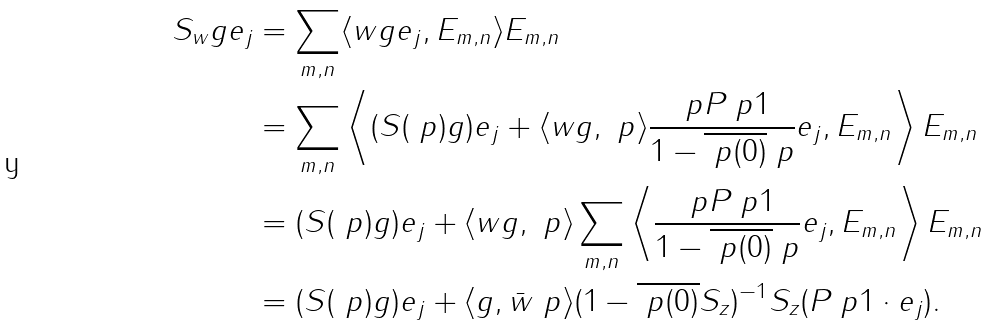Convert formula to latex. <formula><loc_0><loc_0><loc_500><loc_500>S _ { w } g e _ { j } & = \sum _ { m , n } \langle w g e _ { j } , E _ { m , n } \rangle E _ { m , n } \\ & = \sum _ { m , n } \left \langle ( S ( \ p ) g ) e _ { j } + \langle w g , \ p \rangle \frac { \ p P _ { \ } p 1 } { 1 - \overline { \ p ( 0 ) } \ p } e _ { j } , E _ { m , n } \right \rangle E _ { m , n } \\ & = ( S ( \ p ) g ) e _ { j } + \langle w g , \ p \rangle \sum _ { m , n } \left \langle \frac { \ p P _ { \ } p 1 } { 1 - \overline { \ p ( 0 ) } \ p } e _ { j } , E _ { m , n } \right \rangle E _ { m , n } \\ & = ( S ( \ p ) g ) e _ { j } + \langle g , \bar { w } \ p \rangle ( 1 - \overline { \ p ( 0 ) } S _ { z } ) ^ { - 1 } S _ { z } ( P _ { \ } p 1 \cdot e _ { j } ) .</formula> 